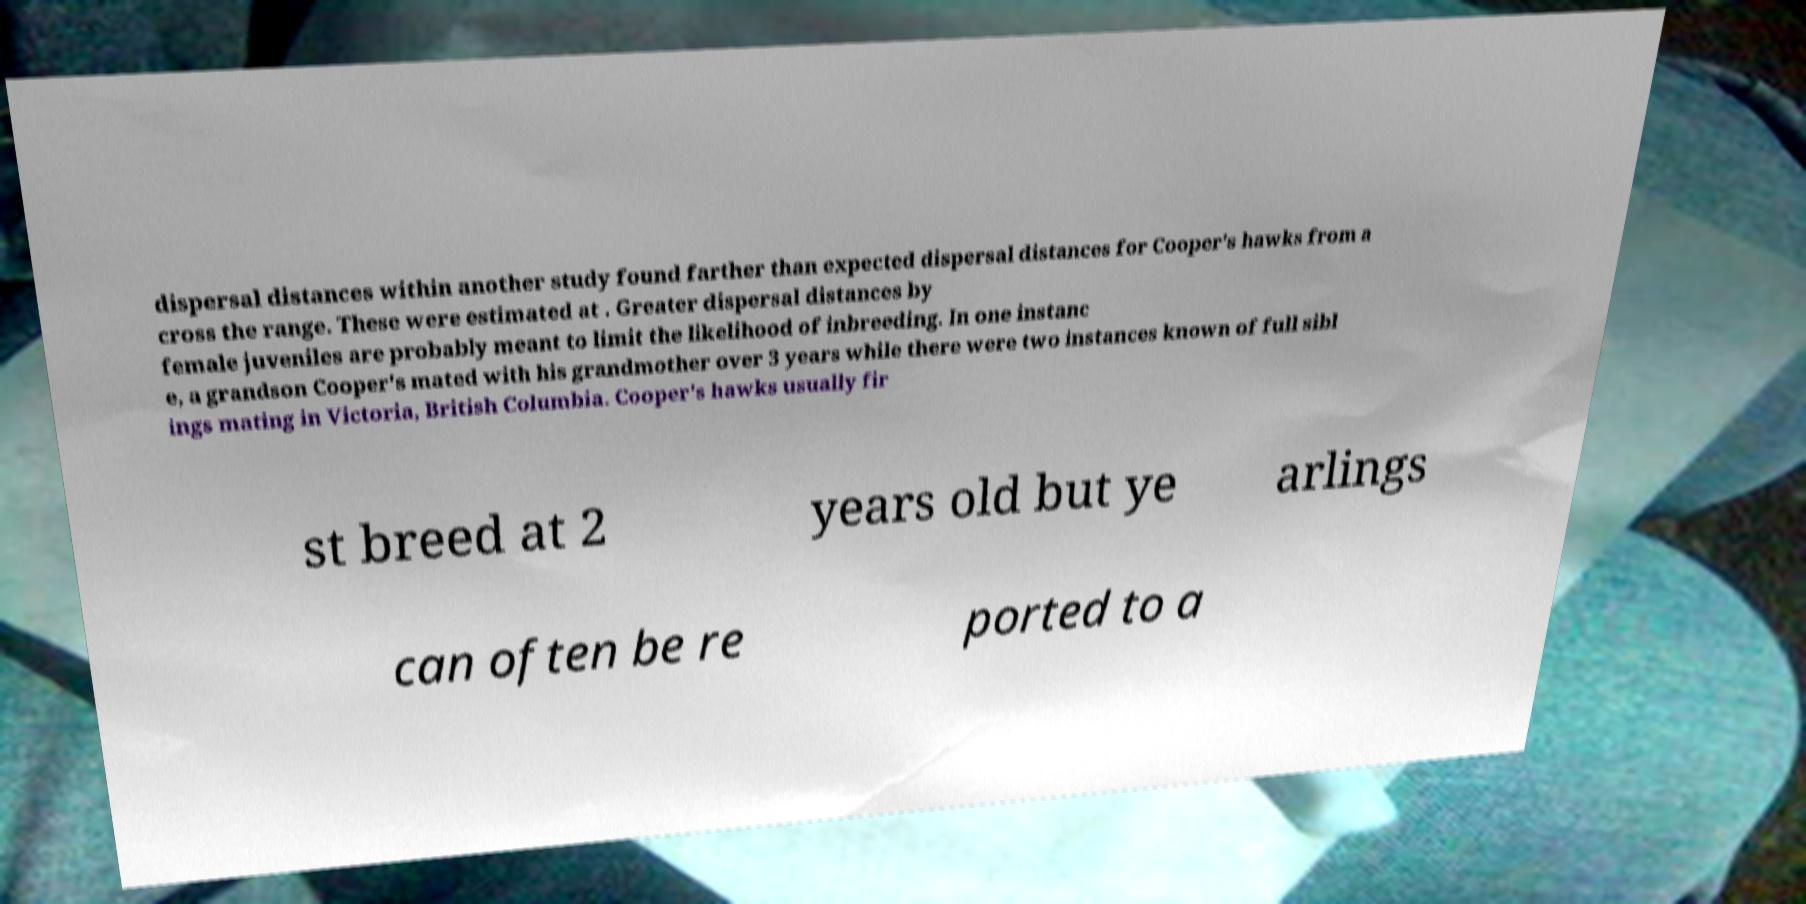There's text embedded in this image that I need extracted. Can you transcribe it verbatim? dispersal distances within another study found farther than expected dispersal distances for Cooper's hawks from a cross the range. These were estimated at . Greater dispersal distances by female juveniles are probably meant to limit the likelihood of inbreeding. In one instanc e, a grandson Cooper's mated with his grandmother over 3 years while there were two instances known of full sibl ings mating in Victoria, British Columbia. Cooper's hawks usually fir st breed at 2 years old but ye arlings can often be re ported to a 